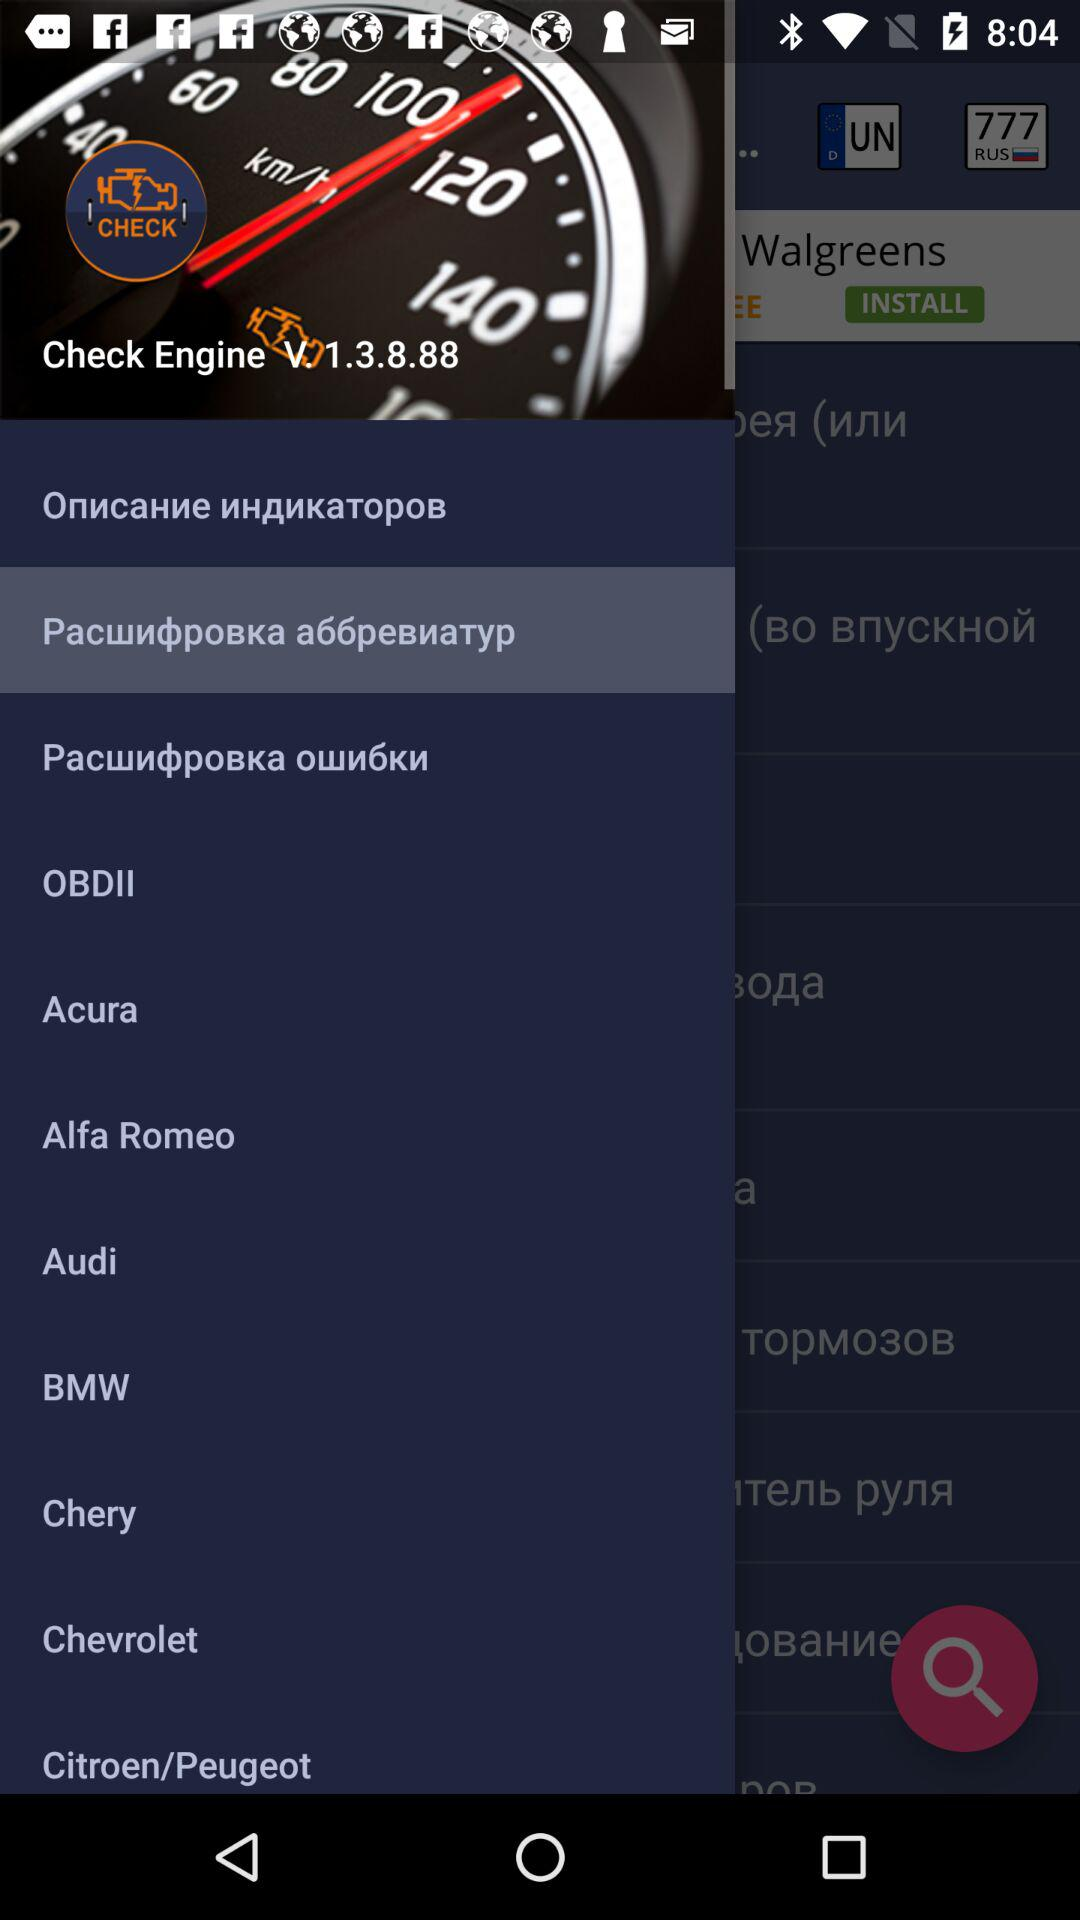What is the version of the "Check Engine"? The version of the "Check Engine" is V. 1.3.8.88. 